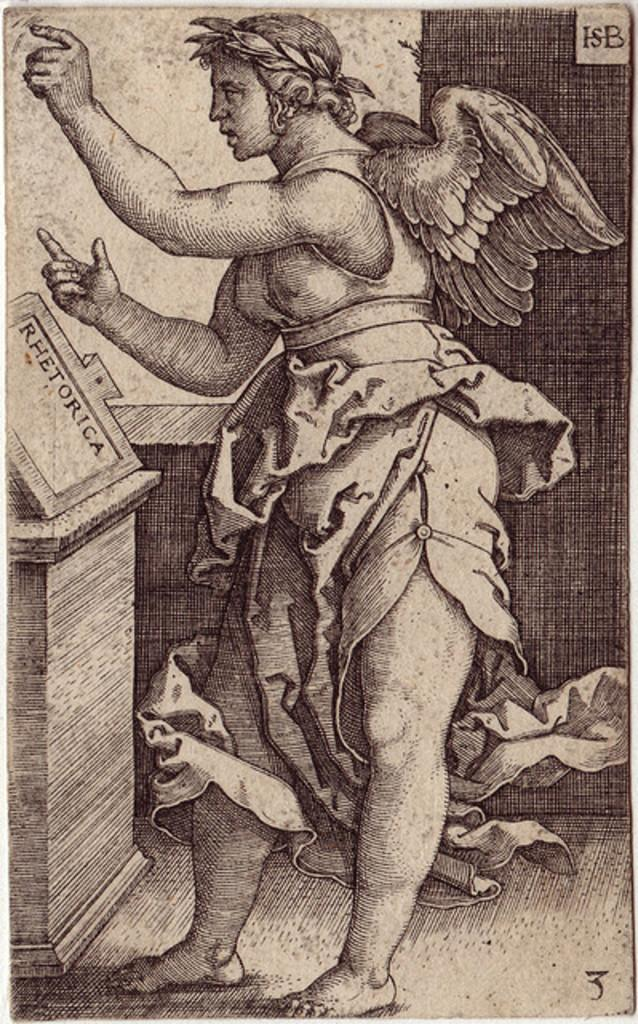What is depicted in the painting in the image? There is a painting of an angel in the image. What object is in front of the angel in the painting? There is a table in front of the angel in the image. What type of lettuce is being used as a centerpiece on the table in the image? There is no lettuce present in the image; the table is in front of the angel in the painting. 